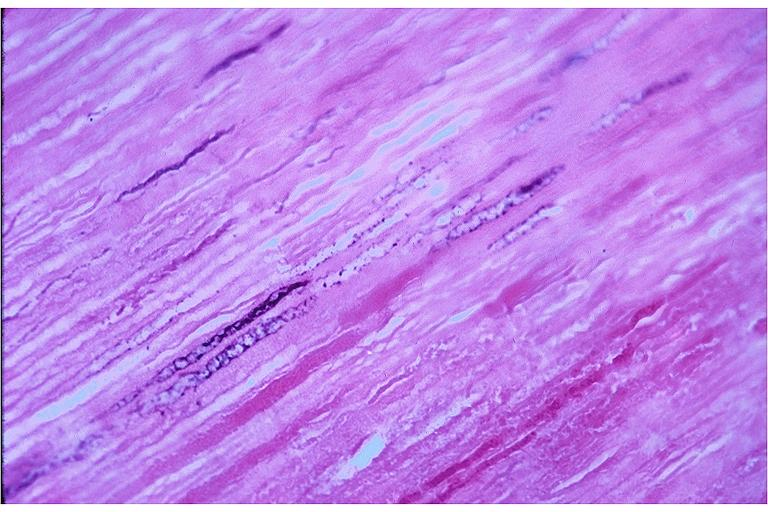what does this image show?
Answer the question using a single word or phrase. Caries 